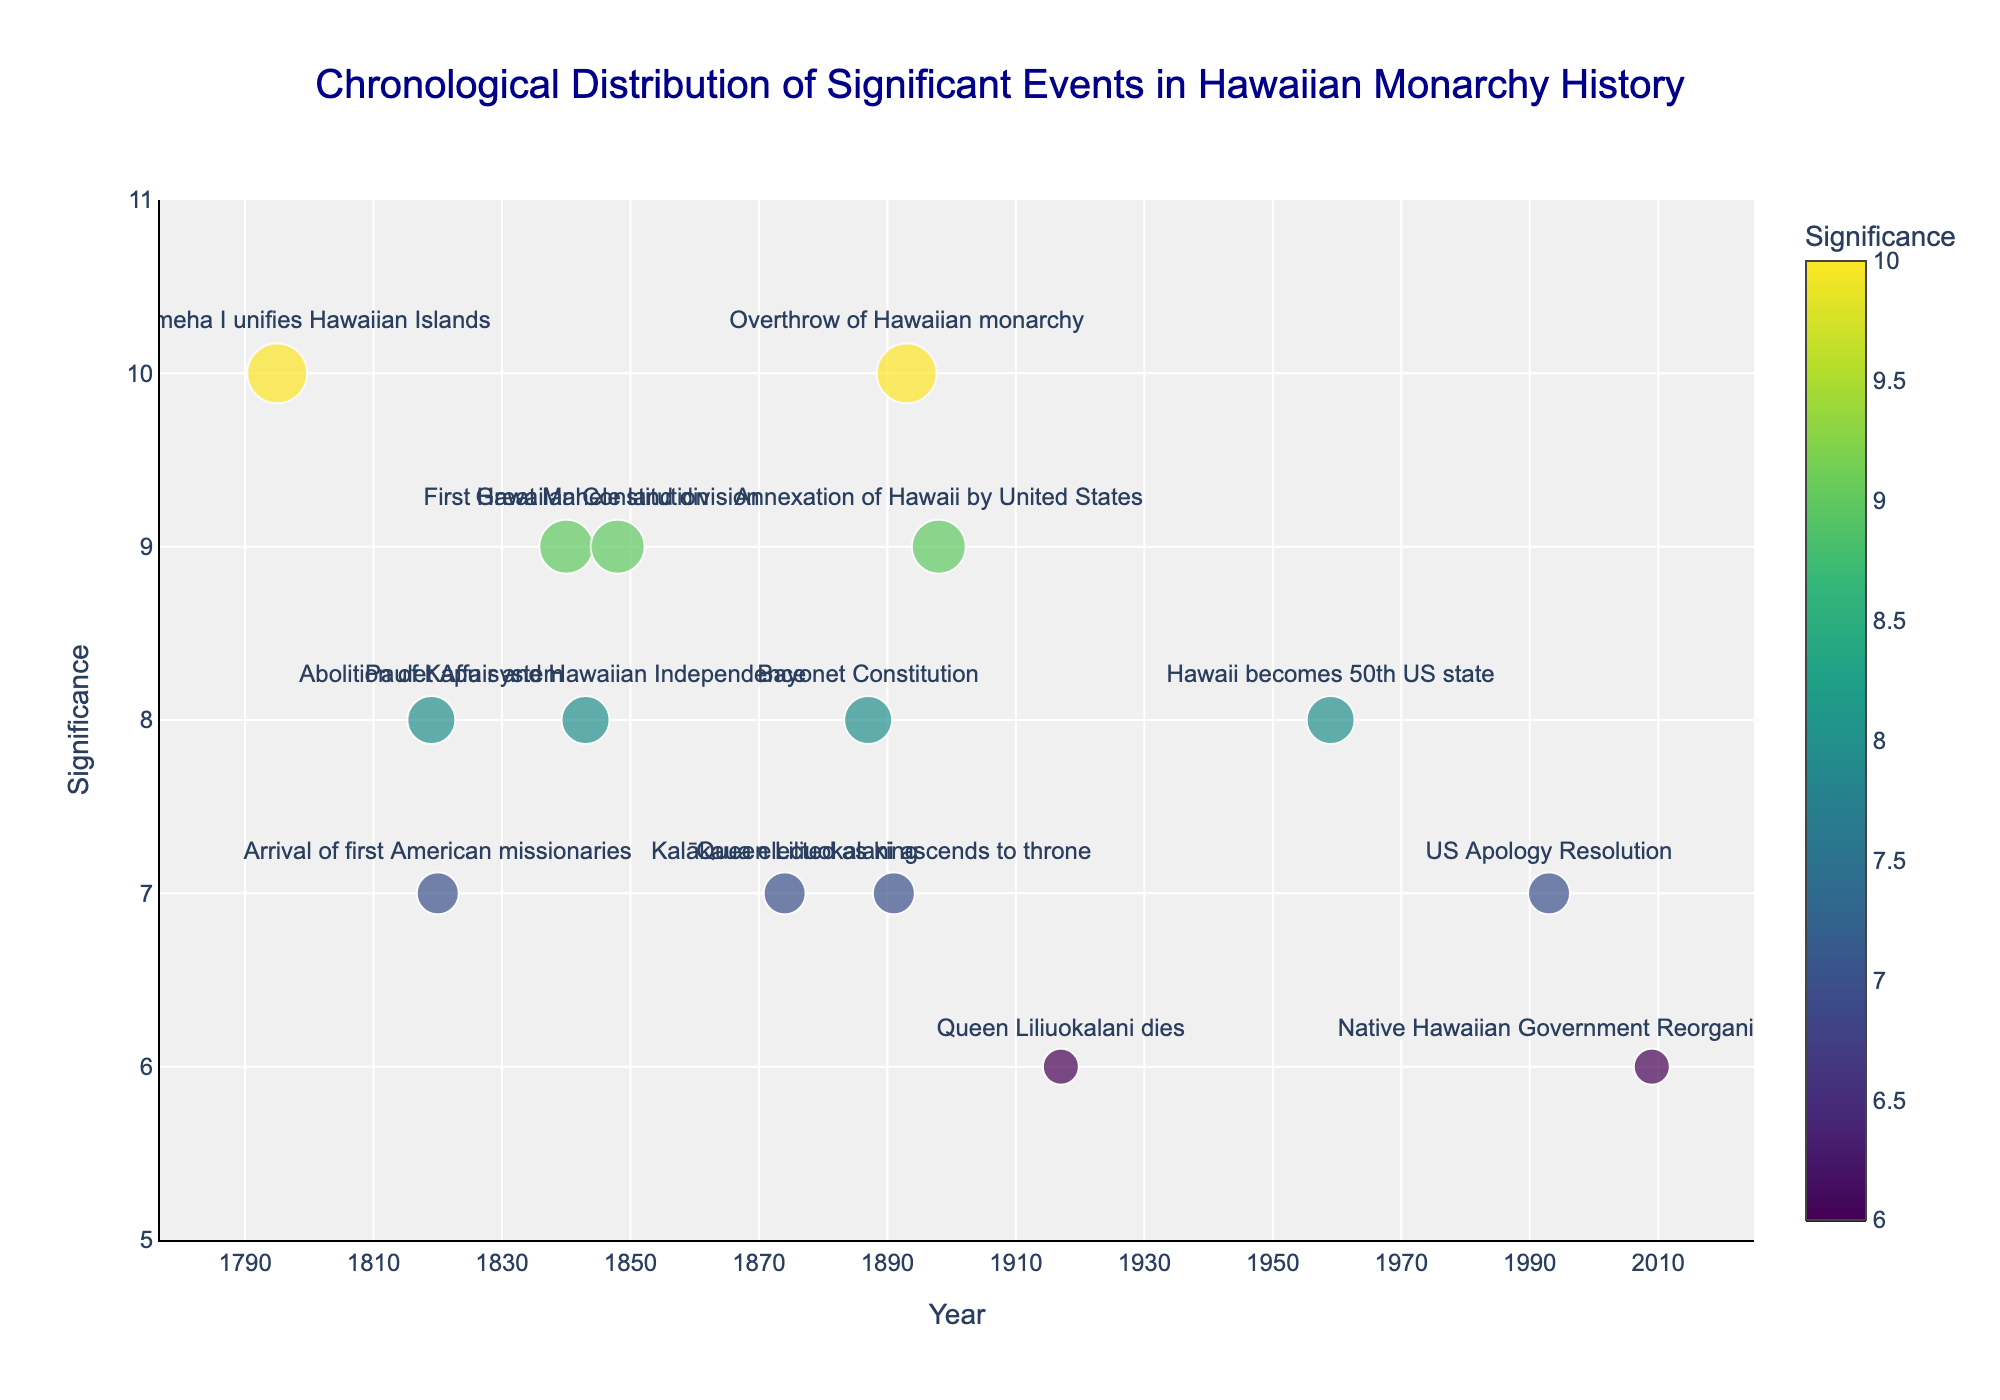What's the most significant event according to the plot? The most significant event according to the plot would be the one with the highest significance value. The event "Kamehameha I unifies Hawaiian Islands" in 1795 and "Overthrow of Hawaiian monarchy" in 1893 both have a significance of 10, but only one should be considered based on visual cues such as size or legend.
Answer: Kamehameha I unifies Hawaiian Islands How many events have a significance value of 10? By looking at the Y-axis and identifying points at the 10 mark, we see that there are two events, "Kamehameha I unifies Hawaiian Islands" in 1795 and "Overthrow of Hawaiian monarchy" in 1893, that reach this significance level.
Answer: 2 What is the range of years represented in the plot? To find the range, look at the X-axis. The first event occurs in 1795, and the last event occurs in 2009.
Answer: 1795-2009 Which event occurred closest to the abolition of the Kapu system in 1819? Look for the year 1819 on the X-axis and then see the next closest event on either side. The arrival of the first American missionaries in 1820 is the closest event.
Answer: Arrival of first American missionaries Between which two events is the largest time gap? Calculate the difference in years between successive points on the X-axis. The largest gap is between 1795 ("Kamehameha I unifies Hawaiian Islands") and 1819 ("Abolition of Kapu system").
Answer: Kamehameha I unifies Hawaiian Islands and Abolition of Kapu system How many events have a significance value of 8? To get this number, count the points that align with the Y-axis value of 8. These events are "Abolition of Kapu system" in 1819, "Paulet Affair and Hawaiian Independence" in 1843, "Bayonet Constitution" in 1887, and "Hawaii becomes 50th US state" in 1959.
Answer: 4 Which event has the lowest significance and when did it occur? Identify the lowest point on the Y-axis. The lowest significance value is 6, which corresponds to "Queen Liliuokalani dies" in 1917 and "Native Hawaiian Government Reorganization Act proposed" in 2009. Either could be mentioned, but the label should clarify which if asking for just one.
Answer: Queen Liliuokalani dies or Native Hawaiian Government Reorganization Act proposed What is the average significance of events that occurred in the 19th century? First, list all 19th-century events: 1795, 1819, 1820, 1840, 1843, 1848, 1874, 1887, 1891, 1893. Their significance values are 10, 8, 7, 9, 8, 9, 7, 8, 7, 10. The sum is 83. There are 10 events, so the average is 83/10.
Answer: 8.3 Which event has a higher significance, the first Hawaiian Constitution or the Great Mahele land division? Examine the plot for the significance values of both events. The First Hawaiian Constitution in 1840 has a significance of 9, and the Great Mahele land division in 1848 also has a significance of 9. Since their values are equal, state so.
Answer: Equal Is there any trend or pattern in the significance of events over time? Look at the overall distribution of the significance values on the Y-axis as they relate to time on the X-axis. Events seem to have a varied significance over time with no clear linear trend, though certain clusters of high significance are notable.
Answer: No clear trend 